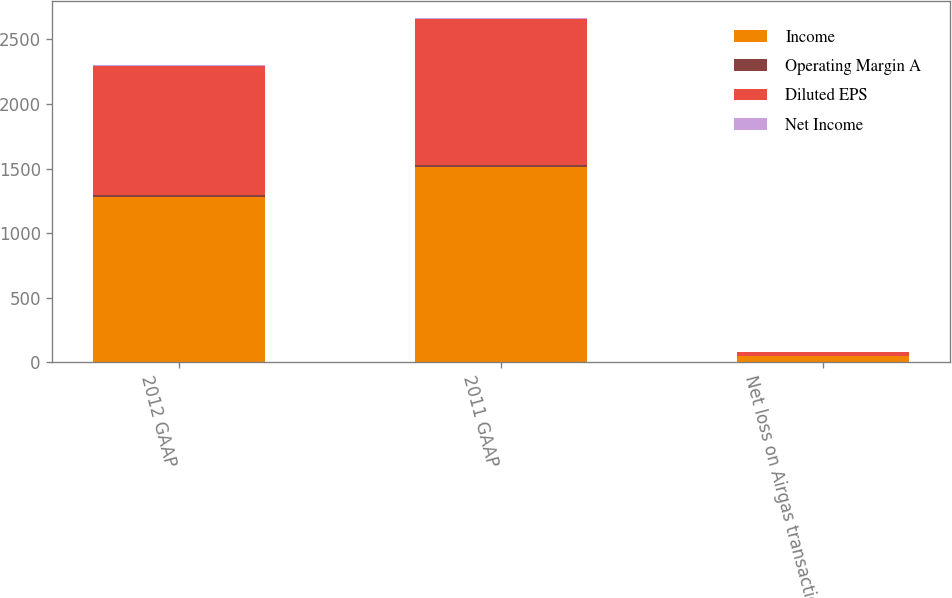Convert chart. <chart><loc_0><loc_0><loc_500><loc_500><stacked_bar_chart><ecel><fcel>2012 GAAP<fcel>2011 GAAP<fcel>Net loss on Airgas transaction<nl><fcel>Income<fcel>1282.4<fcel>1508.1<fcel>48.5<nl><fcel>Operating Margin A<fcel>13.3<fcel>15.6<fcel>0.5<nl><fcel>Diluted EPS<fcel>999.2<fcel>1134.3<fcel>31.6<nl><fcel>Net Income<fcel>4.66<fcel>5.22<fcel>0.14<nl></chart> 